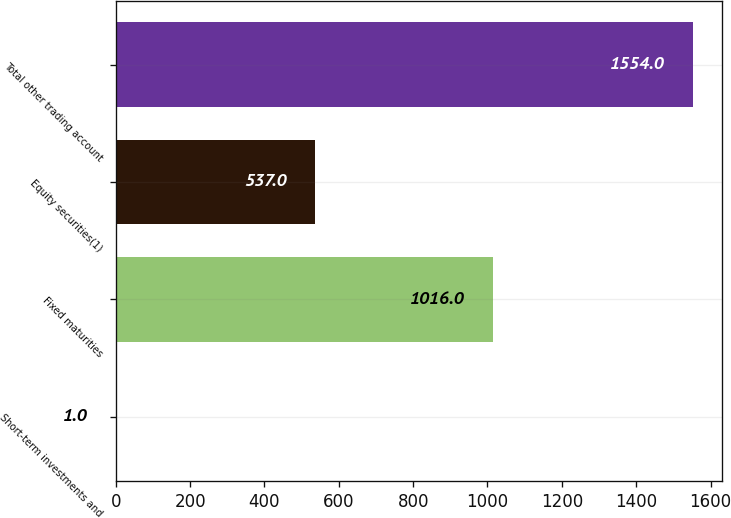Convert chart to OTSL. <chart><loc_0><loc_0><loc_500><loc_500><bar_chart><fcel>Short-term investments and<fcel>Fixed maturities<fcel>Equity securities(1)<fcel>Total other trading account<nl><fcel>1<fcel>1016<fcel>537<fcel>1554<nl></chart> 